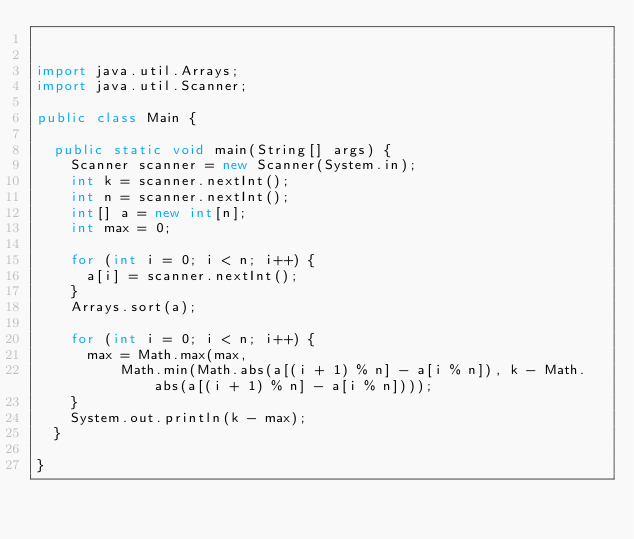Convert code to text. <code><loc_0><loc_0><loc_500><loc_500><_Java_>

import java.util.Arrays;
import java.util.Scanner;

public class Main {

  public static void main(String[] args) {
    Scanner scanner = new Scanner(System.in);
    int k = scanner.nextInt();
    int n = scanner.nextInt();
    int[] a = new int[n];
    int max = 0;

    for (int i = 0; i < n; i++) {
      a[i] = scanner.nextInt();
    }
    Arrays.sort(a);

    for (int i = 0; i < n; i++) {
      max = Math.max(max,
          Math.min(Math.abs(a[(i + 1) % n] - a[i % n]), k - Math.abs(a[(i + 1) % n] - a[i % n])));
    }
    System.out.println(k - max);
  }

}
</code> 